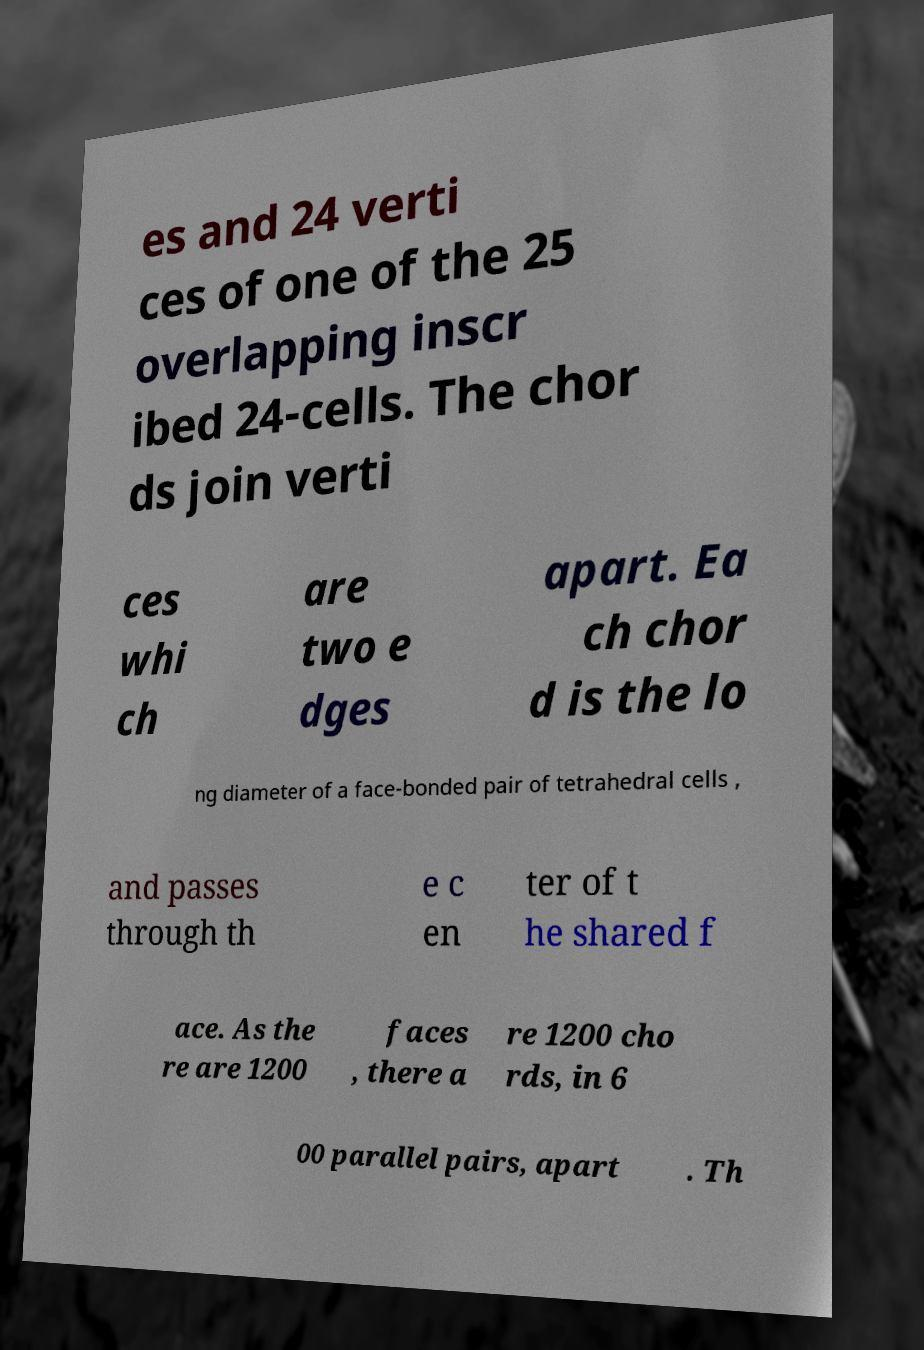Can you read and provide the text displayed in the image?This photo seems to have some interesting text. Can you extract and type it out for me? es and 24 verti ces of one of the 25 overlapping inscr ibed 24-cells. The chor ds join verti ces whi ch are two e dges apart. Ea ch chor d is the lo ng diameter of a face-bonded pair of tetrahedral cells , and passes through th e c en ter of t he shared f ace. As the re are 1200 faces , there a re 1200 cho rds, in 6 00 parallel pairs, apart . Th 